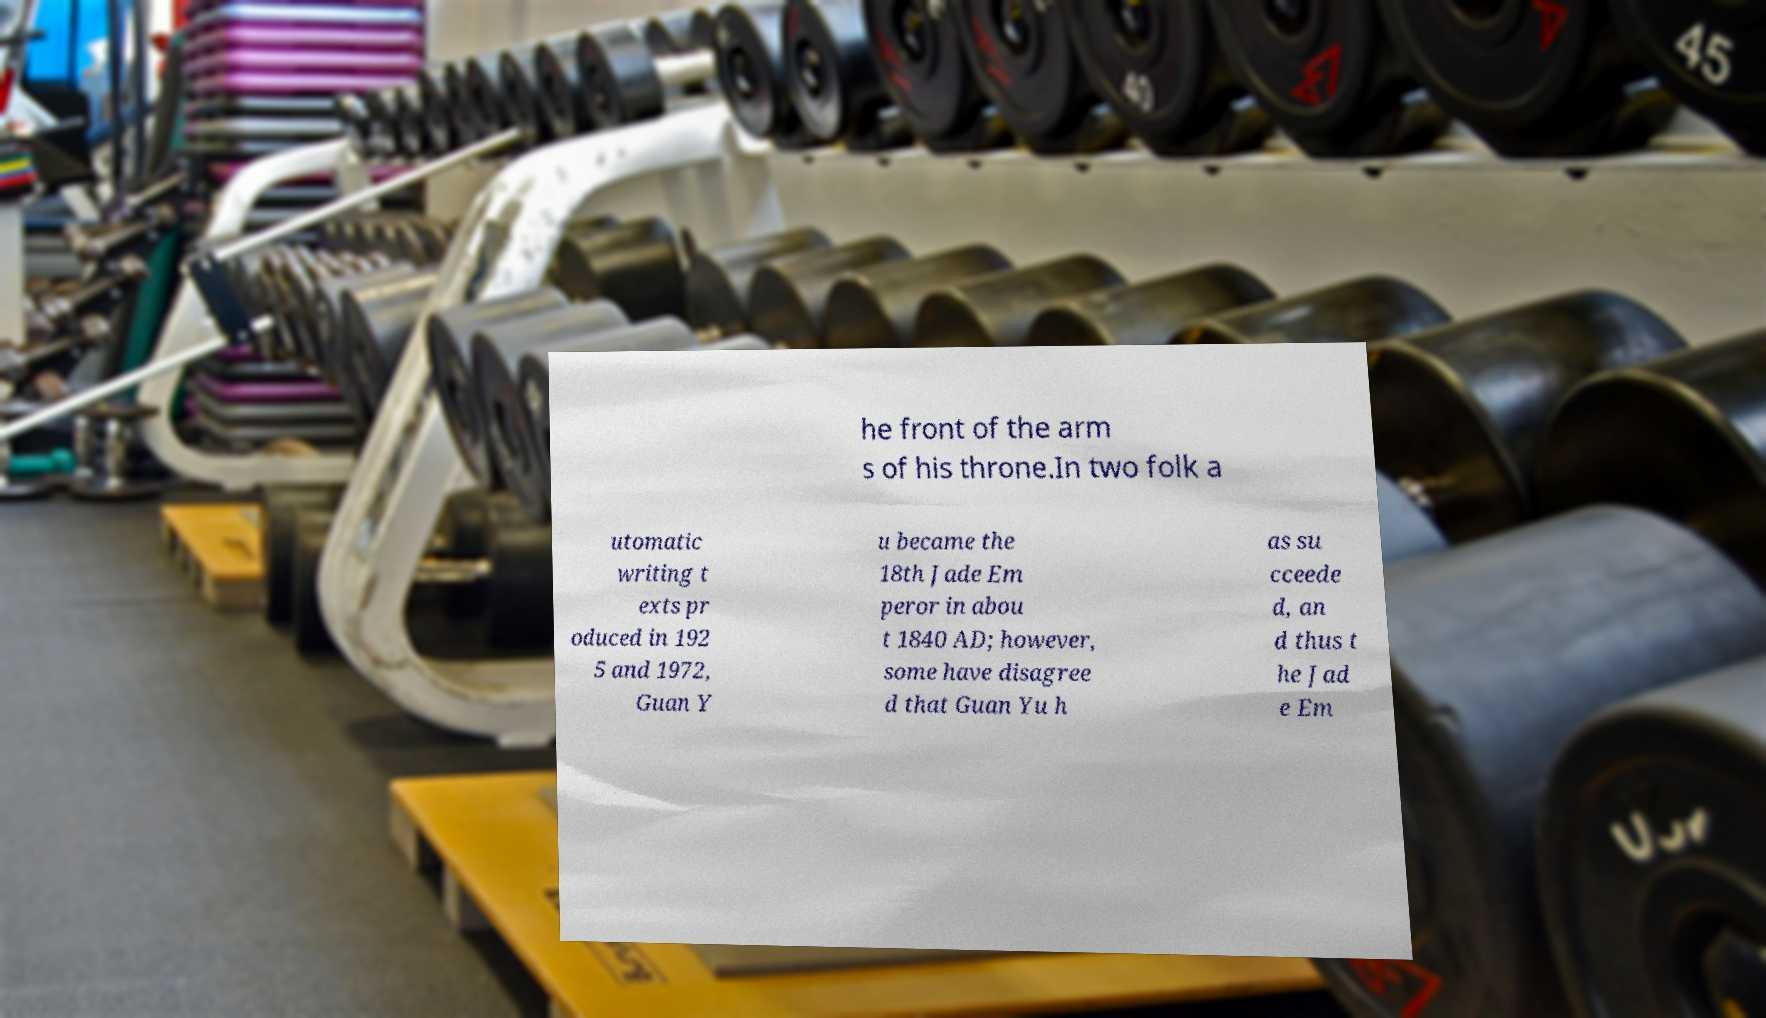For documentation purposes, I need the text within this image transcribed. Could you provide that? he front of the arm s of his throne.In two folk a utomatic writing t exts pr oduced in 192 5 and 1972, Guan Y u became the 18th Jade Em peror in abou t 1840 AD; however, some have disagree d that Guan Yu h as su cceede d, an d thus t he Jad e Em 